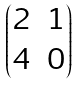<formula> <loc_0><loc_0><loc_500><loc_500>\begin{pmatrix} 2 & 1 \\ 4 & 0 \end{pmatrix}</formula> 